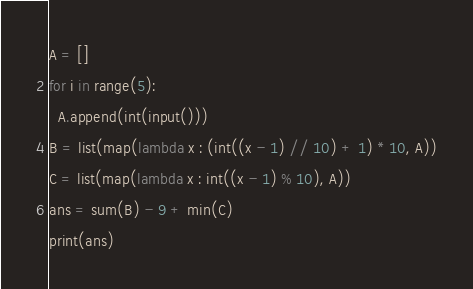<code> <loc_0><loc_0><loc_500><loc_500><_Python_>A = []
for i in range(5):
  A.append(int(input()))
B = list(map(lambda x : (int((x - 1) // 10) + 1) * 10, A))
C = list(map(lambda x : int((x - 1) % 10), A))
ans = sum(B) - 9 + min(C)
print(ans)</code> 